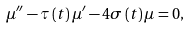Convert formula to latex. <formula><loc_0><loc_0><loc_500><loc_500>\mu ^ { \prime \prime } - \tau \left ( t \right ) \mu ^ { \prime } - 4 \sigma \left ( t \right ) \mu = 0 ,</formula> 